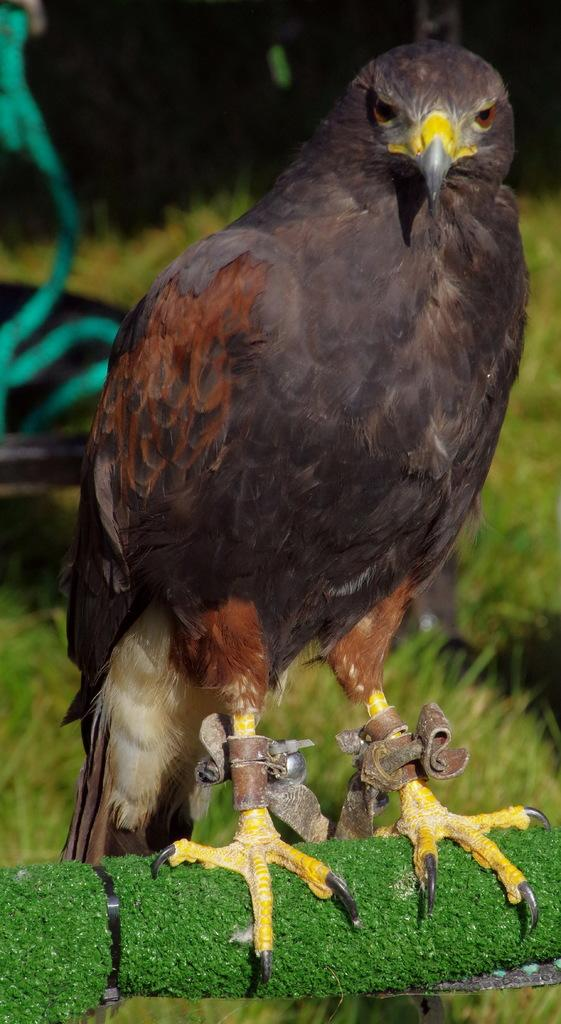What animal is featured in the image? There is an eagle in the image. What type of vegetation can be seen in the background? There is grass in the background of the image. What object is located on the left side of the image? There appears to be a ribbon on the left side of the image. Can you tell me how many bubbles are floating around the girl in the image? There is no girl or bubbles present in the image; it features an eagle and grass in the background. What type of rail is visible in the image? There is no rail present in the image. 